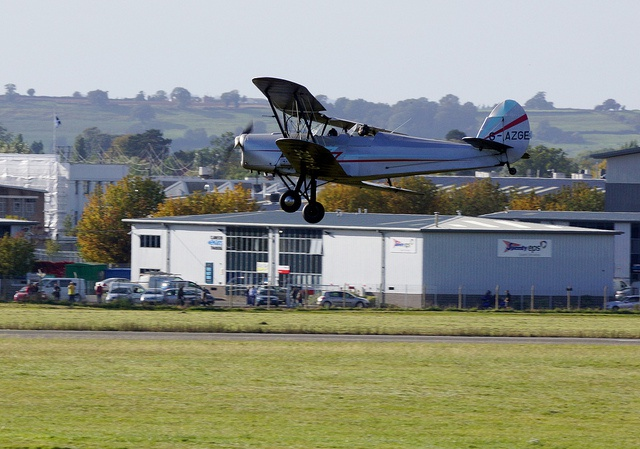Describe the objects in this image and their specific colors. I can see airplane in lightgray, black, gray, and darkblue tones, car in lightgray, gray, black, and darkgray tones, car in lightgray, gray, navy, and black tones, truck in lightgray, gray, and darkgray tones, and car in lightgray, gray, black, and navy tones in this image. 